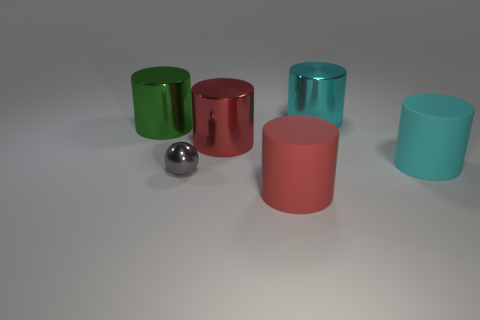Are there any gray shiny balls on the right side of the big cyan cylinder that is in front of the large red thing that is behind the tiny metallic object?
Provide a succinct answer. No. How many other matte cylinders have the same size as the red rubber cylinder?
Your answer should be very brief. 1. There is a large thing that is on the right side of the large cyan thing behind the big cyan rubber cylinder; what is its material?
Give a very brief answer. Rubber. What is the shape of the large matte thing in front of the cyan thing in front of the large cyan object behind the red shiny cylinder?
Your answer should be very brief. Cylinder. Does the big metal thing that is in front of the big green object have the same shape as the rubber thing that is behind the red rubber object?
Offer a terse response. Yes. How many other things are made of the same material as the small gray ball?
Your response must be concise. 3. What is the shape of the cyan thing that is made of the same material as the big green cylinder?
Provide a short and direct response. Cylinder. Does the green metallic cylinder have the same size as the red shiny thing?
Your answer should be very brief. Yes. What size is the cyan cylinder behind the large cyan cylinder that is in front of the big cyan metallic thing?
Your response must be concise. Large. How many blocks are red metallic things or cyan matte things?
Your answer should be compact. 0. 